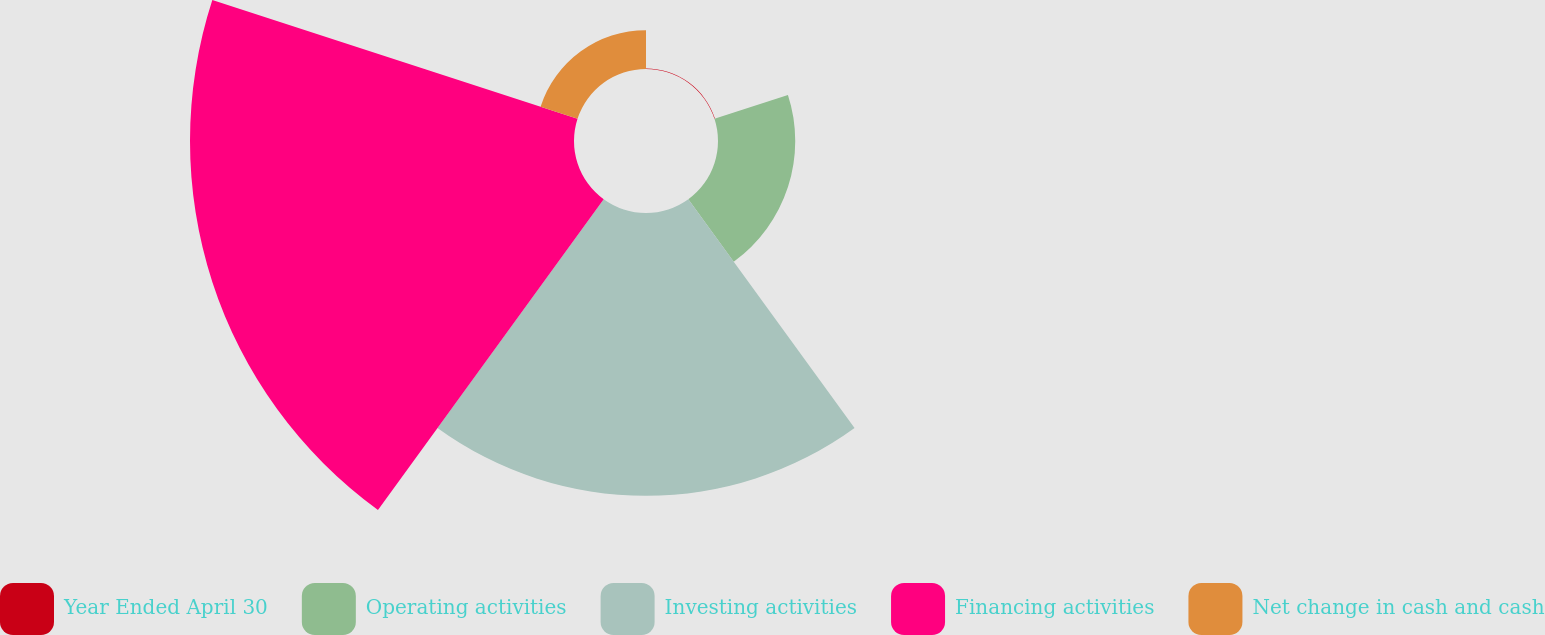Convert chart. <chart><loc_0><loc_0><loc_500><loc_500><pie_chart><fcel>Year Ended April 30<fcel>Operating activities<fcel>Investing activities<fcel>Financing activities<fcel>Net change in cash and cash<nl><fcel>0.06%<fcel>9.86%<fcel>36.1%<fcel>49.02%<fcel>4.96%<nl></chart> 